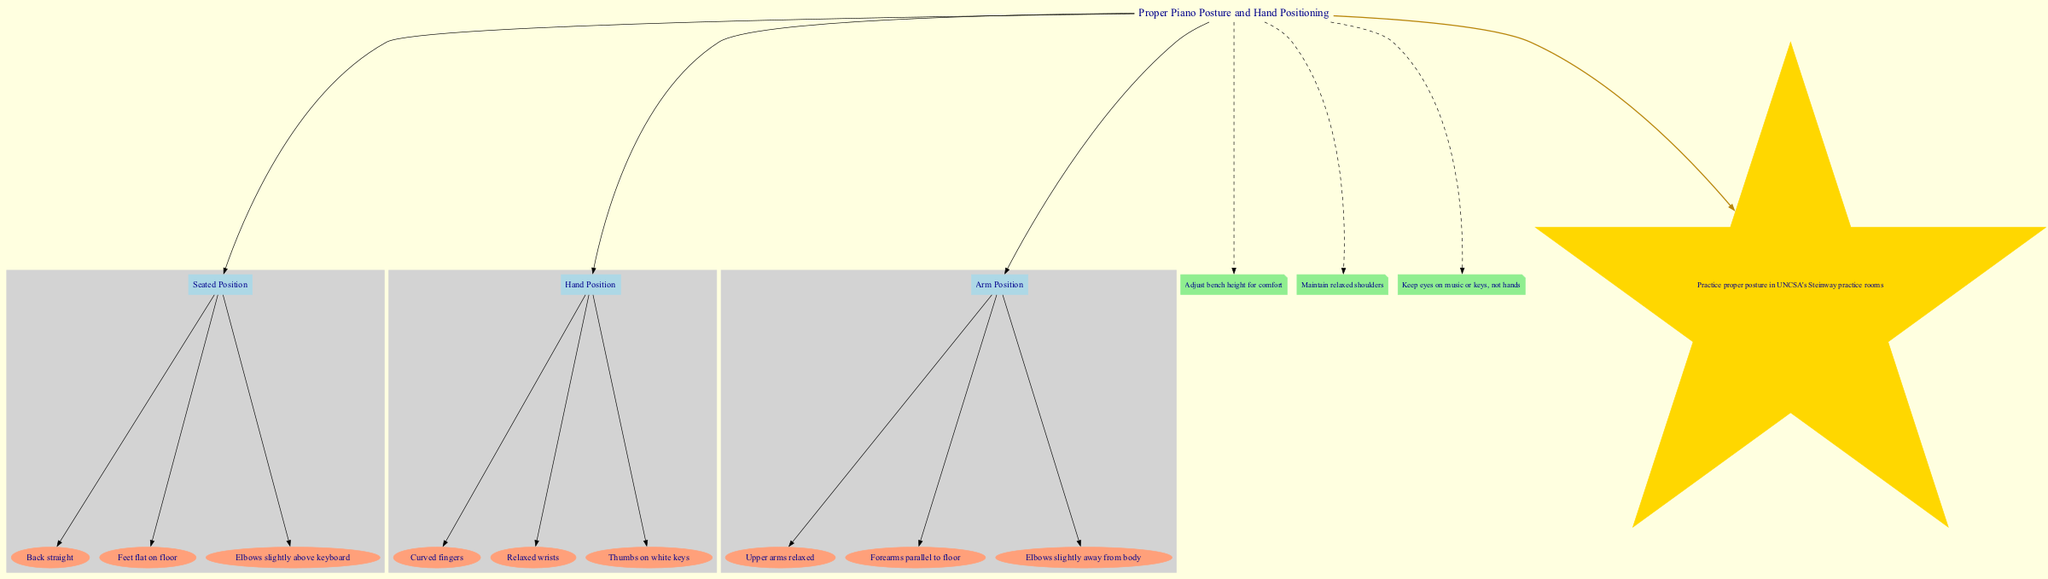What is the title of the diagram? The title of the diagram is located at the top and is clearly mentioned at the beginning of the diagram structure. It states "Proper Piano Posture and Hand Positioning."
Answer: Proper Piano Posture and Hand Positioning How many main elements are listed in the diagram? The diagram lists three main elements: Seated Position, Hand Position, and Arm Position. They can be counted by reviewing the nodes connected directly to the title.
Answer: 3 What is one detail under Seated Position? The details for Seated Position include three aspects: "Back straight," "Feet flat on floor," and "Elbows slightly above keyboard." Any of these can be considered a correct answer.
Answer: Back straight Which positioning detail promotes relaxed arms? Under Arm Position, one detail specifically states "Upper arms relaxed," which directly addresses the relaxation aspect in arm positioning while playing the piano.
Answer: Upper arms relaxed What are the colors used for the main elements? The main elements of the diagram are represented in light blue color as indicated by the filled style attribute for the nodes related to the main elements.
Answer: Light blue Explain one additional note provided in the diagram. The diagram includes additional notes like "Maintain relaxed shoulders," which emphasizes the importance of shoulder relaxation while playing the piano. This note contributes to the overall guidance for maintaining proper posture.
Answer: Maintain relaxed shoulders What shape is used for the detailed elements? The detailed elements for each main section are represented as ellipses, as indicated by the shape attribute defined specifically for those nodes in the diagram.
Answer: Ellipse What is the UNCSA tip mentioned in the diagram? The UNCSA tip is a specific note in the diagram that reads "Practice proper posture in UNCSA's Steinway practice rooms," offering a context-specific suggestion for students using those facilities.
Answer: Practice proper posture in UNCSA's Steinway practice rooms 